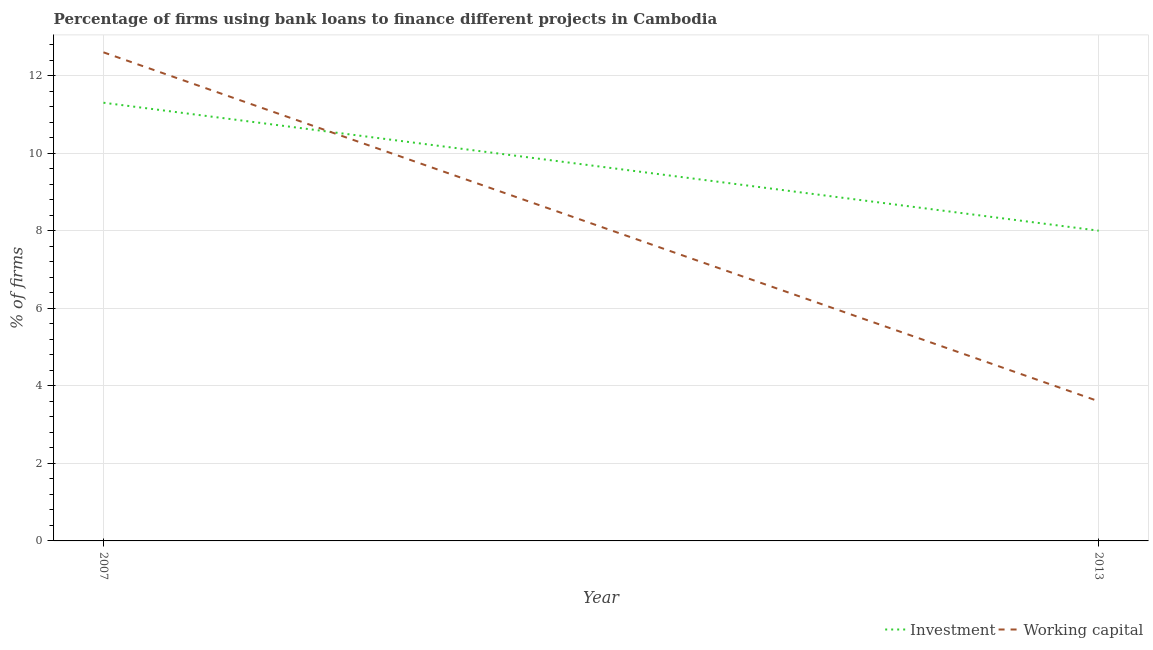Is the number of lines equal to the number of legend labels?
Ensure brevity in your answer.  Yes. What is the percentage of firms using banks to finance working capital in 2013?
Your answer should be compact. 3.6. Across all years, what is the maximum percentage of firms using banks to finance investment?
Your answer should be very brief. 11.3. Across all years, what is the minimum percentage of firms using banks to finance working capital?
Provide a short and direct response. 3.6. What is the total percentage of firms using banks to finance investment in the graph?
Your answer should be very brief. 19.3. What is the difference between the percentage of firms using banks to finance investment in 2007 and that in 2013?
Your response must be concise. 3.3. What is the difference between the percentage of firms using banks to finance working capital in 2013 and the percentage of firms using banks to finance investment in 2007?
Keep it short and to the point. -7.7. What is the average percentage of firms using banks to finance investment per year?
Your answer should be very brief. 9.65. In the year 2013, what is the difference between the percentage of firms using banks to finance investment and percentage of firms using banks to finance working capital?
Provide a succinct answer. 4.4. What is the ratio of the percentage of firms using banks to finance investment in 2007 to that in 2013?
Keep it short and to the point. 1.41. Is the percentage of firms using banks to finance working capital in 2007 less than that in 2013?
Your answer should be very brief. No. In how many years, is the percentage of firms using banks to finance working capital greater than the average percentage of firms using banks to finance working capital taken over all years?
Your answer should be compact. 1. Does the percentage of firms using banks to finance working capital monotonically increase over the years?
Your answer should be very brief. No. How many lines are there?
Offer a terse response. 2. How many years are there in the graph?
Your answer should be very brief. 2. Are the values on the major ticks of Y-axis written in scientific E-notation?
Provide a short and direct response. No. Does the graph contain any zero values?
Keep it short and to the point. No. How many legend labels are there?
Keep it short and to the point. 2. How are the legend labels stacked?
Offer a very short reply. Horizontal. What is the title of the graph?
Make the answer very short. Percentage of firms using bank loans to finance different projects in Cambodia. Does "Young" appear as one of the legend labels in the graph?
Ensure brevity in your answer.  No. What is the label or title of the Y-axis?
Make the answer very short. % of firms. What is the % of firms of Investment in 2007?
Ensure brevity in your answer.  11.3. What is the % of firms of Investment in 2013?
Offer a terse response. 8. What is the % of firms in Working capital in 2013?
Make the answer very short. 3.6. Across all years, what is the maximum % of firms in Investment?
Keep it short and to the point. 11.3. Across all years, what is the minimum % of firms in Investment?
Your response must be concise. 8. Across all years, what is the minimum % of firms in Working capital?
Your answer should be very brief. 3.6. What is the total % of firms of Investment in the graph?
Your answer should be compact. 19.3. What is the difference between the % of firms of Working capital in 2007 and that in 2013?
Make the answer very short. 9. What is the difference between the % of firms of Investment in 2007 and the % of firms of Working capital in 2013?
Provide a short and direct response. 7.7. What is the average % of firms of Investment per year?
Give a very brief answer. 9.65. What is the ratio of the % of firms in Investment in 2007 to that in 2013?
Provide a succinct answer. 1.41. What is the difference between the highest and the second highest % of firms in Investment?
Your answer should be compact. 3.3. What is the difference between the highest and the second highest % of firms in Working capital?
Keep it short and to the point. 9. What is the difference between the highest and the lowest % of firms of Investment?
Your answer should be very brief. 3.3. 